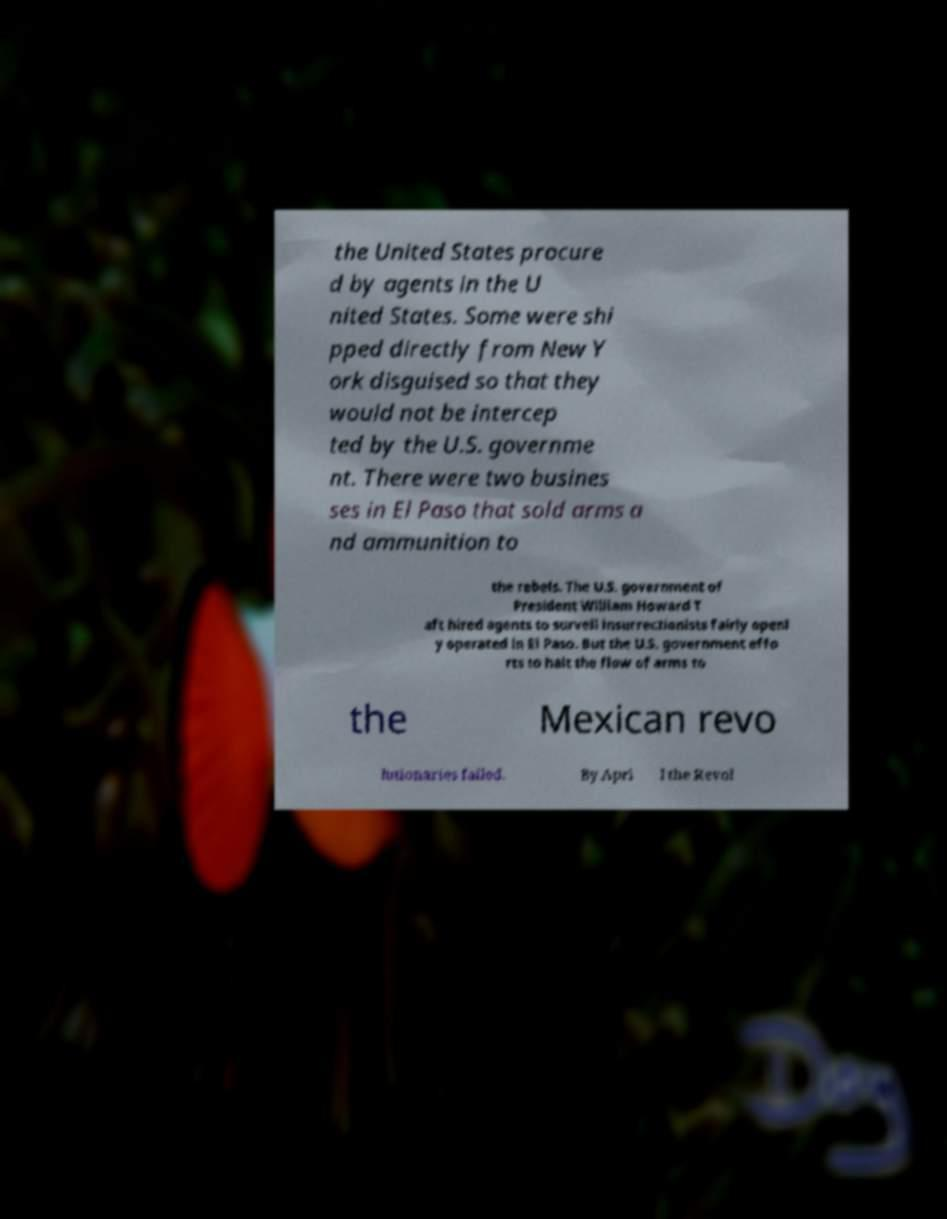There's text embedded in this image that I need extracted. Can you transcribe it verbatim? the United States procure d by agents in the U nited States. Some were shi pped directly from New Y ork disguised so that they would not be intercep ted by the U.S. governme nt. There were two busines ses in El Paso that sold arms a nd ammunition to the rebels. The U.S. government of President William Howard T aft hired agents to surveil insurrectionists fairly openl y operated in El Paso. But the U.S. government effo rts to halt the flow of arms to the Mexican revo lutionaries failed. By Apri l the Revol 